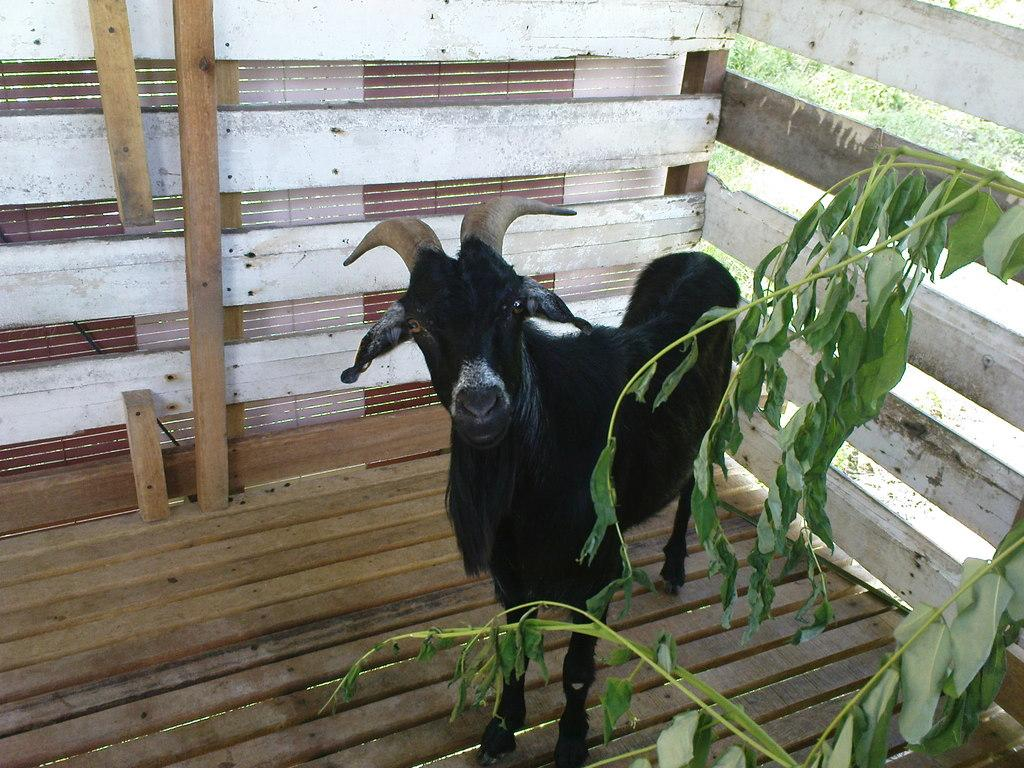What animal is on the wooden platform in the image? There is a goat on a wooden platform in the image. What can be seen in front of the wooden platform? There is a plant in front of the image. What type of barrier is visible in the image? There is a metal fence in the image. How many quills does the goat have in the image? There are no quills present in the image, as goats do not have quills. 